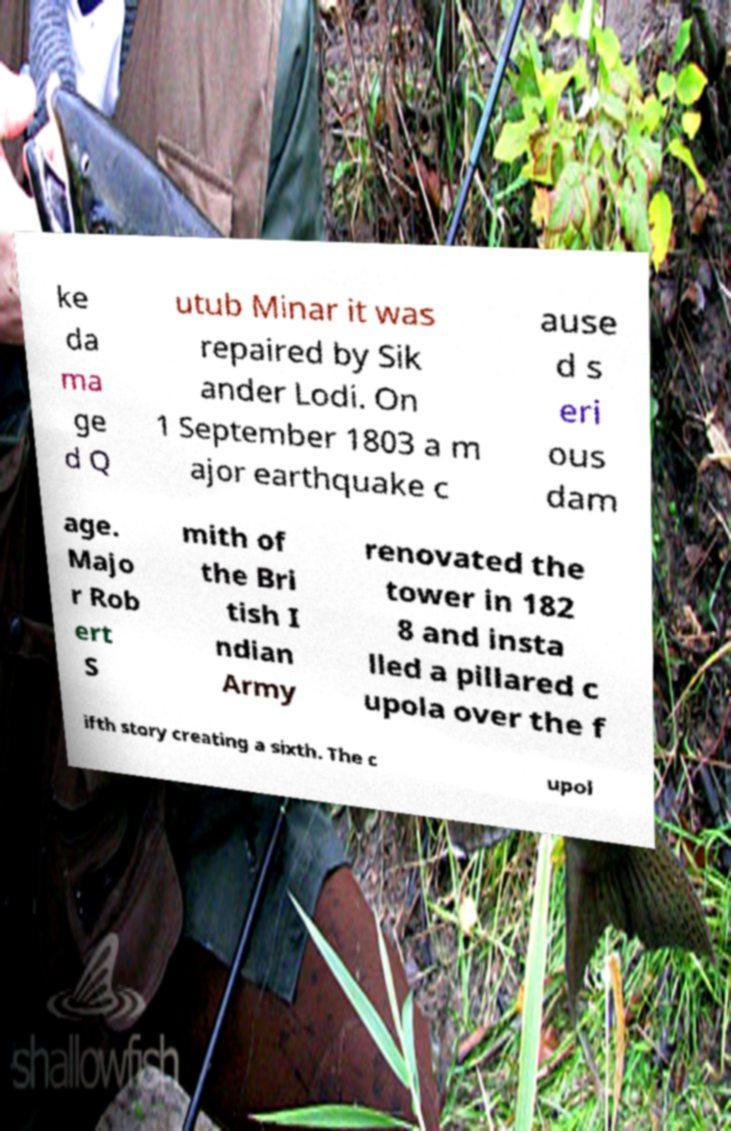Please identify and transcribe the text found in this image. ke da ma ge d Q utub Minar it was repaired by Sik ander Lodi. On 1 September 1803 a m ajor earthquake c ause d s eri ous dam age. Majo r Rob ert S mith of the Bri tish I ndian Army renovated the tower in 182 8 and insta lled a pillared c upola over the f ifth story creating a sixth. The c upol 